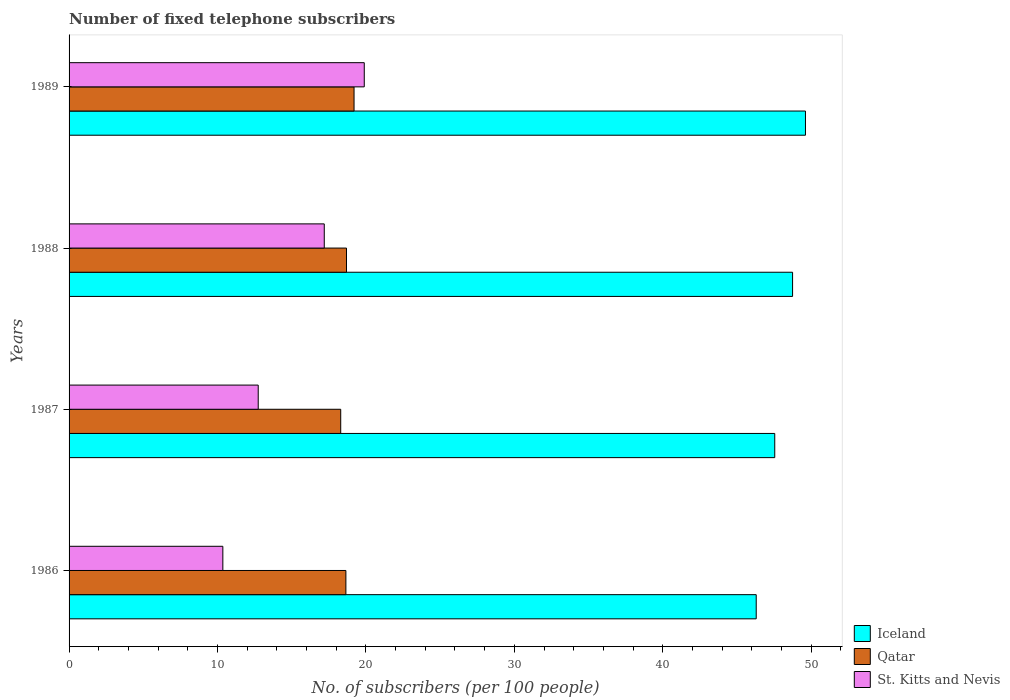Are the number of bars per tick equal to the number of legend labels?
Provide a short and direct response. Yes. Are the number of bars on each tick of the Y-axis equal?
Your answer should be very brief. Yes. How many bars are there on the 1st tick from the top?
Provide a succinct answer. 3. How many bars are there on the 1st tick from the bottom?
Your answer should be very brief. 3. In how many cases, is the number of bars for a given year not equal to the number of legend labels?
Offer a terse response. 0. What is the number of fixed telephone subscribers in Iceland in 1987?
Your answer should be compact. 47.54. Across all years, what is the maximum number of fixed telephone subscribers in Iceland?
Give a very brief answer. 49.61. Across all years, what is the minimum number of fixed telephone subscribers in St. Kitts and Nevis?
Give a very brief answer. 10.36. What is the total number of fixed telephone subscribers in Iceland in the graph?
Offer a very short reply. 192.2. What is the difference between the number of fixed telephone subscribers in Iceland in 1988 and that in 1989?
Make the answer very short. -0.87. What is the difference between the number of fixed telephone subscribers in Iceland in 1989 and the number of fixed telephone subscribers in Qatar in 1986?
Provide a succinct answer. 30.96. What is the average number of fixed telephone subscribers in Iceland per year?
Your answer should be compact. 48.05. In the year 1989, what is the difference between the number of fixed telephone subscribers in Qatar and number of fixed telephone subscribers in St. Kitts and Nevis?
Your answer should be very brief. -0.69. What is the ratio of the number of fixed telephone subscribers in St. Kitts and Nevis in 1987 to that in 1988?
Ensure brevity in your answer.  0.74. Is the number of fixed telephone subscribers in Qatar in 1986 less than that in 1988?
Provide a succinct answer. Yes. What is the difference between the highest and the second highest number of fixed telephone subscribers in St. Kitts and Nevis?
Offer a terse response. 2.69. What is the difference between the highest and the lowest number of fixed telephone subscribers in St. Kitts and Nevis?
Provide a succinct answer. 9.53. Is the sum of the number of fixed telephone subscribers in Qatar in 1988 and 1989 greater than the maximum number of fixed telephone subscribers in St. Kitts and Nevis across all years?
Offer a very short reply. Yes. What does the 3rd bar from the top in 1988 represents?
Offer a very short reply. Iceland. What does the 1st bar from the bottom in 1989 represents?
Keep it short and to the point. Iceland. Are the values on the major ticks of X-axis written in scientific E-notation?
Give a very brief answer. No. Does the graph contain any zero values?
Provide a succinct answer. No. How many legend labels are there?
Make the answer very short. 3. How are the legend labels stacked?
Offer a terse response. Vertical. What is the title of the graph?
Make the answer very short. Number of fixed telephone subscribers. Does "Azerbaijan" appear as one of the legend labels in the graph?
Keep it short and to the point. No. What is the label or title of the X-axis?
Ensure brevity in your answer.  No. of subscribers (per 100 people). What is the No. of subscribers (per 100 people) in Iceland in 1986?
Ensure brevity in your answer.  46.3. What is the No. of subscribers (per 100 people) in Qatar in 1986?
Your answer should be compact. 18.65. What is the No. of subscribers (per 100 people) in St. Kitts and Nevis in 1986?
Ensure brevity in your answer.  10.36. What is the No. of subscribers (per 100 people) in Iceland in 1987?
Offer a very short reply. 47.54. What is the No. of subscribers (per 100 people) of Qatar in 1987?
Your answer should be compact. 18.3. What is the No. of subscribers (per 100 people) of St. Kitts and Nevis in 1987?
Offer a very short reply. 12.74. What is the No. of subscribers (per 100 people) in Iceland in 1988?
Your answer should be compact. 48.75. What is the No. of subscribers (per 100 people) in Qatar in 1988?
Your answer should be compact. 18.69. What is the No. of subscribers (per 100 people) in St. Kitts and Nevis in 1988?
Ensure brevity in your answer.  17.19. What is the No. of subscribers (per 100 people) of Iceland in 1989?
Provide a succinct answer. 49.61. What is the No. of subscribers (per 100 people) of Qatar in 1989?
Ensure brevity in your answer.  19.2. What is the No. of subscribers (per 100 people) of St. Kitts and Nevis in 1989?
Your answer should be very brief. 19.89. Across all years, what is the maximum No. of subscribers (per 100 people) of Iceland?
Your answer should be compact. 49.61. Across all years, what is the maximum No. of subscribers (per 100 people) of Qatar?
Make the answer very short. 19.2. Across all years, what is the maximum No. of subscribers (per 100 people) of St. Kitts and Nevis?
Your answer should be very brief. 19.89. Across all years, what is the minimum No. of subscribers (per 100 people) of Iceland?
Offer a very short reply. 46.3. Across all years, what is the minimum No. of subscribers (per 100 people) in Qatar?
Provide a succinct answer. 18.3. Across all years, what is the minimum No. of subscribers (per 100 people) in St. Kitts and Nevis?
Your response must be concise. 10.36. What is the total No. of subscribers (per 100 people) in Iceland in the graph?
Offer a terse response. 192.2. What is the total No. of subscribers (per 100 people) of Qatar in the graph?
Provide a short and direct response. 74.84. What is the total No. of subscribers (per 100 people) in St. Kitts and Nevis in the graph?
Your response must be concise. 60.19. What is the difference between the No. of subscribers (per 100 people) of Iceland in 1986 and that in 1987?
Provide a succinct answer. -1.25. What is the difference between the No. of subscribers (per 100 people) of Qatar in 1986 and that in 1987?
Give a very brief answer. 0.35. What is the difference between the No. of subscribers (per 100 people) of St. Kitts and Nevis in 1986 and that in 1987?
Offer a terse response. -2.38. What is the difference between the No. of subscribers (per 100 people) in Iceland in 1986 and that in 1988?
Ensure brevity in your answer.  -2.45. What is the difference between the No. of subscribers (per 100 people) of Qatar in 1986 and that in 1988?
Provide a succinct answer. -0.04. What is the difference between the No. of subscribers (per 100 people) of St. Kitts and Nevis in 1986 and that in 1988?
Your answer should be compact. -6.83. What is the difference between the No. of subscribers (per 100 people) in Iceland in 1986 and that in 1989?
Provide a short and direct response. -3.32. What is the difference between the No. of subscribers (per 100 people) of Qatar in 1986 and that in 1989?
Offer a very short reply. -0.55. What is the difference between the No. of subscribers (per 100 people) in St. Kitts and Nevis in 1986 and that in 1989?
Ensure brevity in your answer.  -9.53. What is the difference between the No. of subscribers (per 100 people) in Iceland in 1987 and that in 1988?
Make the answer very short. -1.2. What is the difference between the No. of subscribers (per 100 people) in Qatar in 1987 and that in 1988?
Your response must be concise. -0.39. What is the difference between the No. of subscribers (per 100 people) in St. Kitts and Nevis in 1987 and that in 1988?
Your answer should be compact. -4.45. What is the difference between the No. of subscribers (per 100 people) of Iceland in 1987 and that in 1989?
Your response must be concise. -2.07. What is the difference between the No. of subscribers (per 100 people) of Qatar in 1987 and that in 1989?
Provide a short and direct response. -0.9. What is the difference between the No. of subscribers (per 100 people) of St. Kitts and Nevis in 1987 and that in 1989?
Give a very brief answer. -7.14. What is the difference between the No. of subscribers (per 100 people) of Iceland in 1988 and that in 1989?
Keep it short and to the point. -0.87. What is the difference between the No. of subscribers (per 100 people) of Qatar in 1988 and that in 1989?
Your answer should be compact. -0.51. What is the difference between the No. of subscribers (per 100 people) of St. Kitts and Nevis in 1988 and that in 1989?
Give a very brief answer. -2.69. What is the difference between the No. of subscribers (per 100 people) in Iceland in 1986 and the No. of subscribers (per 100 people) in Qatar in 1987?
Your answer should be very brief. 27.99. What is the difference between the No. of subscribers (per 100 people) in Iceland in 1986 and the No. of subscribers (per 100 people) in St. Kitts and Nevis in 1987?
Provide a short and direct response. 33.55. What is the difference between the No. of subscribers (per 100 people) in Qatar in 1986 and the No. of subscribers (per 100 people) in St. Kitts and Nevis in 1987?
Provide a succinct answer. 5.91. What is the difference between the No. of subscribers (per 100 people) of Iceland in 1986 and the No. of subscribers (per 100 people) of Qatar in 1988?
Make the answer very short. 27.6. What is the difference between the No. of subscribers (per 100 people) of Iceland in 1986 and the No. of subscribers (per 100 people) of St. Kitts and Nevis in 1988?
Give a very brief answer. 29.1. What is the difference between the No. of subscribers (per 100 people) of Qatar in 1986 and the No. of subscribers (per 100 people) of St. Kitts and Nevis in 1988?
Offer a terse response. 1.46. What is the difference between the No. of subscribers (per 100 people) of Iceland in 1986 and the No. of subscribers (per 100 people) of Qatar in 1989?
Give a very brief answer. 27.09. What is the difference between the No. of subscribers (per 100 people) of Iceland in 1986 and the No. of subscribers (per 100 people) of St. Kitts and Nevis in 1989?
Your response must be concise. 26.41. What is the difference between the No. of subscribers (per 100 people) of Qatar in 1986 and the No. of subscribers (per 100 people) of St. Kitts and Nevis in 1989?
Keep it short and to the point. -1.24. What is the difference between the No. of subscribers (per 100 people) in Iceland in 1987 and the No. of subscribers (per 100 people) in Qatar in 1988?
Ensure brevity in your answer.  28.85. What is the difference between the No. of subscribers (per 100 people) in Iceland in 1987 and the No. of subscribers (per 100 people) in St. Kitts and Nevis in 1988?
Your answer should be compact. 30.35. What is the difference between the No. of subscribers (per 100 people) in Qatar in 1987 and the No. of subscribers (per 100 people) in St. Kitts and Nevis in 1988?
Give a very brief answer. 1.11. What is the difference between the No. of subscribers (per 100 people) of Iceland in 1987 and the No. of subscribers (per 100 people) of Qatar in 1989?
Offer a very short reply. 28.34. What is the difference between the No. of subscribers (per 100 people) of Iceland in 1987 and the No. of subscribers (per 100 people) of St. Kitts and Nevis in 1989?
Provide a succinct answer. 27.66. What is the difference between the No. of subscribers (per 100 people) of Qatar in 1987 and the No. of subscribers (per 100 people) of St. Kitts and Nevis in 1989?
Make the answer very short. -1.59. What is the difference between the No. of subscribers (per 100 people) in Iceland in 1988 and the No. of subscribers (per 100 people) in Qatar in 1989?
Your response must be concise. 29.54. What is the difference between the No. of subscribers (per 100 people) of Iceland in 1988 and the No. of subscribers (per 100 people) of St. Kitts and Nevis in 1989?
Keep it short and to the point. 28.86. What is the difference between the No. of subscribers (per 100 people) of Qatar in 1988 and the No. of subscribers (per 100 people) of St. Kitts and Nevis in 1989?
Offer a very short reply. -1.2. What is the average No. of subscribers (per 100 people) in Iceland per year?
Make the answer very short. 48.05. What is the average No. of subscribers (per 100 people) in Qatar per year?
Ensure brevity in your answer.  18.71. What is the average No. of subscribers (per 100 people) of St. Kitts and Nevis per year?
Provide a succinct answer. 15.05. In the year 1986, what is the difference between the No. of subscribers (per 100 people) in Iceland and No. of subscribers (per 100 people) in Qatar?
Give a very brief answer. 27.65. In the year 1986, what is the difference between the No. of subscribers (per 100 people) of Iceland and No. of subscribers (per 100 people) of St. Kitts and Nevis?
Ensure brevity in your answer.  35.94. In the year 1986, what is the difference between the No. of subscribers (per 100 people) in Qatar and No. of subscribers (per 100 people) in St. Kitts and Nevis?
Give a very brief answer. 8.29. In the year 1987, what is the difference between the No. of subscribers (per 100 people) of Iceland and No. of subscribers (per 100 people) of Qatar?
Your response must be concise. 29.24. In the year 1987, what is the difference between the No. of subscribers (per 100 people) of Iceland and No. of subscribers (per 100 people) of St. Kitts and Nevis?
Provide a short and direct response. 34.8. In the year 1987, what is the difference between the No. of subscribers (per 100 people) in Qatar and No. of subscribers (per 100 people) in St. Kitts and Nevis?
Make the answer very short. 5.56. In the year 1988, what is the difference between the No. of subscribers (per 100 people) of Iceland and No. of subscribers (per 100 people) of Qatar?
Give a very brief answer. 30.05. In the year 1988, what is the difference between the No. of subscribers (per 100 people) in Iceland and No. of subscribers (per 100 people) in St. Kitts and Nevis?
Give a very brief answer. 31.55. In the year 1988, what is the difference between the No. of subscribers (per 100 people) in Qatar and No. of subscribers (per 100 people) in St. Kitts and Nevis?
Offer a very short reply. 1.5. In the year 1989, what is the difference between the No. of subscribers (per 100 people) of Iceland and No. of subscribers (per 100 people) of Qatar?
Offer a very short reply. 30.41. In the year 1989, what is the difference between the No. of subscribers (per 100 people) of Iceland and No. of subscribers (per 100 people) of St. Kitts and Nevis?
Give a very brief answer. 29.73. In the year 1989, what is the difference between the No. of subscribers (per 100 people) in Qatar and No. of subscribers (per 100 people) in St. Kitts and Nevis?
Offer a very short reply. -0.69. What is the ratio of the No. of subscribers (per 100 people) in Iceland in 1986 to that in 1987?
Make the answer very short. 0.97. What is the ratio of the No. of subscribers (per 100 people) in Qatar in 1986 to that in 1987?
Offer a very short reply. 1.02. What is the ratio of the No. of subscribers (per 100 people) in St. Kitts and Nevis in 1986 to that in 1987?
Your response must be concise. 0.81. What is the ratio of the No. of subscribers (per 100 people) in Iceland in 1986 to that in 1988?
Your answer should be compact. 0.95. What is the ratio of the No. of subscribers (per 100 people) in St. Kitts and Nevis in 1986 to that in 1988?
Keep it short and to the point. 0.6. What is the ratio of the No. of subscribers (per 100 people) of Iceland in 1986 to that in 1989?
Give a very brief answer. 0.93. What is the ratio of the No. of subscribers (per 100 people) in Qatar in 1986 to that in 1989?
Your answer should be compact. 0.97. What is the ratio of the No. of subscribers (per 100 people) in St. Kitts and Nevis in 1986 to that in 1989?
Provide a short and direct response. 0.52. What is the ratio of the No. of subscribers (per 100 people) in Iceland in 1987 to that in 1988?
Your answer should be very brief. 0.98. What is the ratio of the No. of subscribers (per 100 people) in Qatar in 1987 to that in 1988?
Ensure brevity in your answer.  0.98. What is the ratio of the No. of subscribers (per 100 people) of St. Kitts and Nevis in 1987 to that in 1988?
Provide a succinct answer. 0.74. What is the ratio of the No. of subscribers (per 100 people) of Qatar in 1987 to that in 1989?
Provide a short and direct response. 0.95. What is the ratio of the No. of subscribers (per 100 people) of St. Kitts and Nevis in 1987 to that in 1989?
Ensure brevity in your answer.  0.64. What is the ratio of the No. of subscribers (per 100 people) of Iceland in 1988 to that in 1989?
Provide a short and direct response. 0.98. What is the ratio of the No. of subscribers (per 100 people) in Qatar in 1988 to that in 1989?
Make the answer very short. 0.97. What is the ratio of the No. of subscribers (per 100 people) in St. Kitts and Nevis in 1988 to that in 1989?
Keep it short and to the point. 0.86. What is the difference between the highest and the second highest No. of subscribers (per 100 people) in Iceland?
Your response must be concise. 0.87. What is the difference between the highest and the second highest No. of subscribers (per 100 people) of Qatar?
Keep it short and to the point. 0.51. What is the difference between the highest and the second highest No. of subscribers (per 100 people) in St. Kitts and Nevis?
Keep it short and to the point. 2.69. What is the difference between the highest and the lowest No. of subscribers (per 100 people) in Iceland?
Make the answer very short. 3.32. What is the difference between the highest and the lowest No. of subscribers (per 100 people) of Qatar?
Your response must be concise. 0.9. What is the difference between the highest and the lowest No. of subscribers (per 100 people) of St. Kitts and Nevis?
Give a very brief answer. 9.53. 